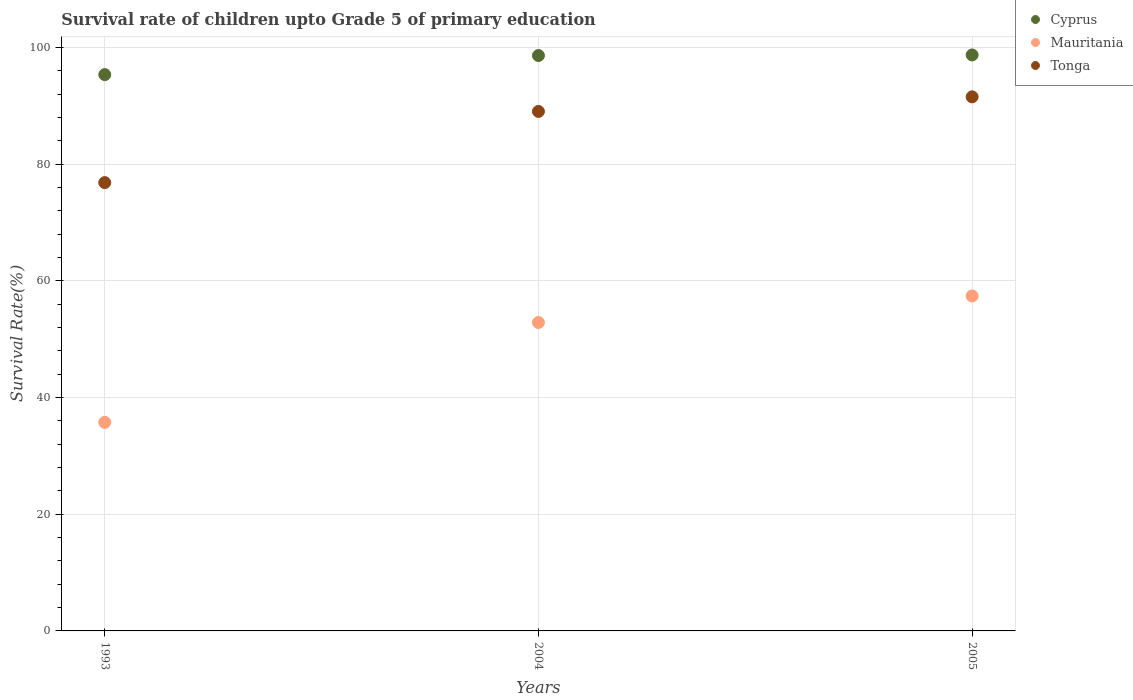How many different coloured dotlines are there?
Your answer should be compact. 3. What is the survival rate of children in Tonga in 1993?
Give a very brief answer. 76.85. Across all years, what is the maximum survival rate of children in Mauritania?
Your answer should be very brief. 57.42. Across all years, what is the minimum survival rate of children in Mauritania?
Provide a succinct answer. 35.75. In which year was the survival rate of children in Cyprus maximum?
Provide a succinct answer. 2005. In which year was the survival rate of children in Cyprus minimum?
Provide a succinct answer. 1993. What is the total survival rate of children in Cyprus in the graph?
Your answer should be very brief. 292.74. What is the difference between the survival rate of children in Mauritania in 2004 and that in 2005?
Offer a terse response. -4.54. What is the difference between the survival rate of children in Mauritania in 2004 and the survival rate of children in Cyprus in 2005?
Give a very brief answer. -45.86. What is the average survival rate of children in Mauritania per year?
Offer a very short reply. 48.68. In the year 2004, what is the difference between the survival rate of children in Mauritania and survival rate of children in Tonga?
Your answer should be compact. -36.18. What is the ratio of the survival rate of children in Cyprus in 1993 to that in 2004?
Ensure brevity in your answer.  0.97. Is the difference between the survival rate of children in Mauritania in 1993 and 2005 greater than the difference between the survival rate of children in Tonga in 1993 and 2005?
Make the answer very short. No. What is the difference between the highest and the second highest survival rate of children in Tonga?
Your response must be concise. 2.5. What is the difference between the highest and the lowest survival rate of children in Cyprus?
Offer a terse response. 3.37. In how many years, is the survival rate of children in Mauritania greater than the average survival rate of children in Mauritania taken over all years?
Offer a terse response. 2. Is the sum of the survival rate of children in Mauritania in 2004 and 2005 greater than the maximum survival rate of children in Tonga across all years?
Your answer should be compact. Yes. Is it the case that in every year, the sum of the survival rate of children in Tonga and survival rate of children in Mauritania  is greater than the survival rate of children in Cyprus?
Provide a short and direct response. Yes. Does the survival rate of children in Tonga monotonically increase over the years?
Provide a succinct answer. Yes. Is the survival rate of children in Mauritania strictly greater than the survival rate of children in Tonga over the years?
Ensure brevity in your answer.  No. Is the survival rate of children in Tonga strictly less than the survival rate of children in Cyprus over the years?
Provide a short and direct response. Yes. How many dotlines are there?
Your answer should be compact. 3. Does the graph contain any zero values?
Give a very brief answer. No. Does the graph contain grids?
Give a very brief answer. Yes. What is the title of the graph?
Ensure brevity in your answer.  Survival rate of children upto Grade 5 of primary education. What is the label or title of the Y-axis?
Offer a very short reply. Survival Rate(%). What is the Survival Rate(%) in Cyprus in 1993?
Your response must be concise. 95.36. What is the Survival Rate(%) in Mauritania in 1993?
Keep it short and to the point. 35.75. What is the Survival Rate(%) in Tonga in 1993?
Your answer should be compact. 76.85. What is the Survival Rate(%) in Cyprus in 2004?
Give a very brief answer. 98.64. What is the Survival Rate(%) of Mauritania in 2004?
Offer a terse response. 52.88. What is the Survival Rate(%) in Tonga in 2004?
Offer a very short reply. 89.05. What is the Survival Rate(%) of Cyprus in 2005?
Your answer should be compact. 98.74. What is the Survival Rate(%) in Mauritania in 2005?
Provide a short and direct response. 57.42. What is the Survival Rate(%) in Tonga in 2005?
Offer a very short reply. 91.55. Across all years, what is the maximum Survival Rate(%) of Cyprus?
Make the answer very short. 98.74. Across all years, what is the maximum Survival Rate(%) of Mauritania?
Give a very brief answer. 57.42. Across all years, what is the maximum Survival Rate(%) of Tonga?
Offer a terse response. 91.55. Across all years, what is the minimum Survival Rate(%) of Cyprus?
Give a very brief answer. 95.36. Across all years, what is the minimum Survival Rate(%) of Mauritania?
Provide a succinct answer. 35.75. Across all years, what is the minimum Survival Rate(%) of Tonga?
Your answer should be compact. 76.85. What is the total Survival Rate(%) of Cyprus in the graph?
Provide a succinct answer. 292.74. What is the total Survival Rate(%) in Mauritania in the graph?
Offer a terse response. 146.05. What is the total Survival Rate(%) of Tonga in the graph?
Offer a terse response. 257.46. What is the difference between the Survival Rate(%) in Cyprus in 1993 and that in 2004?
Offer a very short reply. -3.27. What is the difference between the Survival Rate(%) in Mauritania in 1993 and that in 2004?
Provide a succinct answer. -17.13. What is the difference between the Survival Rate(%) in Tonga in 1993 and that in 2004?
Your answer should be compact. -12.2. What is the difference between the Survival Rate(%) of Cyprus in 1993 and that in 2005?
Your response must be concise. -3.37. What is the difference between the Survival Rate(%) in Mauritania in 1993 and that in 2005?
Give a very brief answer. -21.67. What is the difference between the Survival Rate(%) in Tonga in 1993 and that in 2005?
Your answer should be compact. -14.7. What is the difference between the Survival Rate(%) in Cyprus in 2004 and that in 2005?
Keep it short and to the point. -0.1. What is the difference between the Survival Rate(%) of Mauritania in 2004 and that in 2005?
Provide a short and direct response. -4.54. What is the difference between the Survival Rate(%) of Tonga in 2004 and that in 2005?
Your answer should be very brief. -2.5. What is the difference between the Survival Rate(%) of Cyprus in 1993 and the Survival Rate(%) of Mauritania in 2004?
Offer a terse response. 42.49. What is the difference between the Survival Rate(%) of Cyprus in 1993 and the Survival Rate(%) of Tonga in 2004?
Offer a very short reply. 6.31. What is the difference between the Survival Rate(%) of Mauritania in 1993 and the Survival Rate(%) of Tonga in 2004?
Provide a succinct answer. -53.3. What is the difference between the Survival Rate(%) of Cyprus in 1993 and the Survival Rate(%) of Mauritania in 2005?
Provide a short and direct response. 37.95. What is the difference between the Survival Rate(%) in Cyprus in 1993 and the Survival Rate(%) in Tonga in 2005?
Ensure brevity in your answer.  3.81. What is the difference between the Survival Rate(%) in Mauritania in 1993 and the Survival Rate(%) in Tonga in 2005?
Your answer should be very brief. -55.8. What is the difference between the Survival Rate(%) in Cyprus in 2004 and the Survival Rate(%) in Mauritania in 2005?
Provide a succinct answer. 41.22. What is the difference between the Survival Rate(%) in Cyprus in 2004 and the Survival Rate(%) in Tonga in 2005?
Ensure brevity in your answer.  7.08. What is the difference between the Survival Rate(%) in Mauritania in 2004 and the Survival Rate(%) in Tonga in 2005?
Your answer should be compact. -38.68. What is the average Survival Rate(%) in Cyprus per year?
Your answer should be compact. 97.58. What is the average Survival Rate(%) of Mauritania per year?
Offer a terse response. 48.68. What is the average Survival Rate(%) in Tonga per year?
Offer a terse response. 85.82. In the year 1993, what is the difference between the Survival Rate(%) in Cyprus and Survival Rate(%) in Mauritania?
Make the answer very short. 59.61. In the year 1993, what is the difference between the Survival Rate(%) in Cyprus and Survival Rate(%) in Tonga?
Your answer should be very brief. 18.51. In the year 1993, what is the difference between the Survival Rate(%) of Mauritania and Survival Rate(%) of Tonga?
Give a very brief answer. -41.1. In the year 2004, what is the difference between the Survival Rate(%) of Cyprus and Survival Rate(%) of Mauritania?
Give a very brief answer. 45.76. In the year 2004, what is the difference between the Survival Rate(%) of Cyprus and Survival Rate(%) of Tonga?
Your answer should be very brief. 9.58. In the year 2004, what is the difference between the Survival Rate(%) of Mauritania and Survival Rate(%) of Tonga?
Make the answer very short. -36.18. In the year 2005, what is the difference between the Survival Rate(%) of Cyprus and Survival Rate(%) of Mauritania?
Provide a short and direct response. 41.32. In the year 2005, what is the difference between the Survival Rate(%) of Cyprus and Survival Rate(%) of Tonga?
Ensure brevity in your answer.  7.18. In the year 2005, what is the difference between the Survival Rate(%) of Mauritania and Survival Rate(%) of Tonga?
Offer a very short reply. -34.14. What is the ratio of the Survival Rate(%) in Cyprus in 1993 to that in 2004?
Provide a short and direct response. 0.97. What is the ratio of the Survival Rate(%) of Mauritania in 1993 to that in 2004?
Ensure brevity in your answer.  0.68. What is the ratio of the Survival Rate(%) in Tonga in 1993 to that in 2004?
Offer a terse response. 0.86. What is the ratio of the Survival Rate(%) of Cyprus in 1993 to that in 2005?
Provide a short and direct response. 0.97. What is the ratio of the Survival Rate(%) of Mauritania in 1993 to that in 2005?
Provide a short and direct response. 0.62. What is the ratio of the Survival Rate(%) of Tonga in 1993 to that in 2005?
Ensure brevity in your answer.  0.84. What is the ratio of the Survival Rate(%) of Cyprus in 2004 to that in 2005?
Keep it short and to the point. 1. What is the ratio of the Survival Rate(%) of Mauritania in 2004 to that in 2005?
Offer a terse response. 0.92. What is the ratio of the Survival Rate(%) of Tonga in 2004 to that in 2005?
Provide a succinct answer. 0.97. What is the difference between the highest and the second highest Survival Rate(%) in Cyprus?
Provide a succinct answer. 0.1. What is the difference between the highest and the second highest Survival Rate(%) in Mauritania?
Offer a terse response. 4.54. What is the difference between the highest and the second highest Survival Rate(%) of Tonga?
Offer a very short reply. 2.5. What is the difference between the highest and the lowest Survival Rate(%) in Cyprus?
Provide a succinct answer. 3.37. What is the difference between the highest and the lowest Survival Rate(%) in Mauritania?
Your answer should be very brief. 21.67. What is the difference between the highest and the lowest Survival Rate(%) of Tonga?
Ensure brevity in your answer.  14.7. 